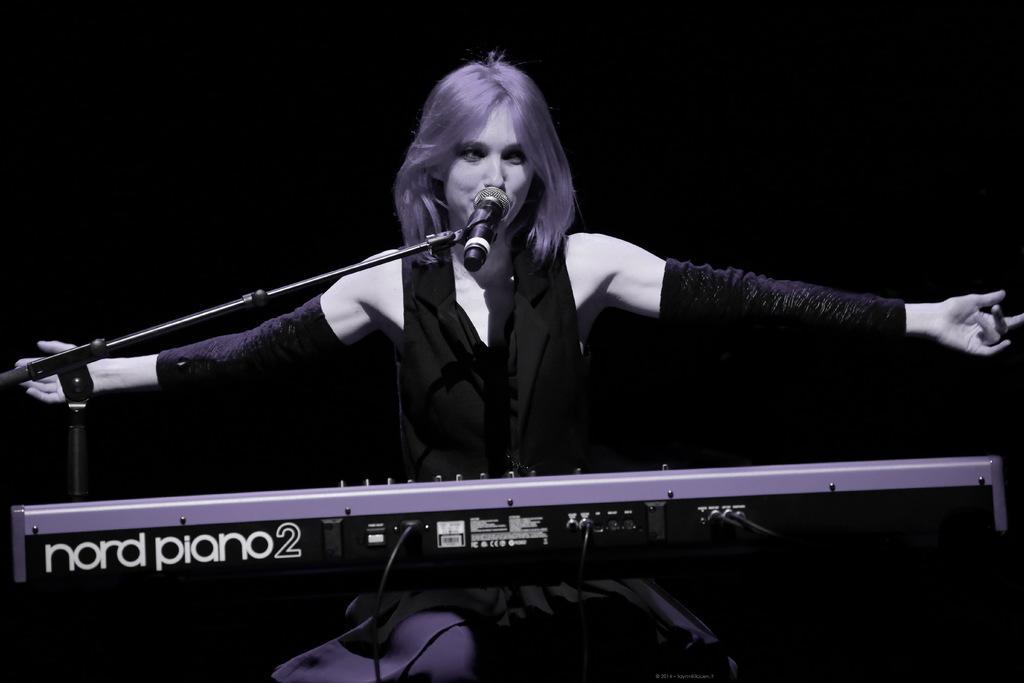Please provide a concise description of this image. In this image there is a piano with some text written on it and there is a stand and on the stand there is a mic and in the center there is a woman sitting and singing. 